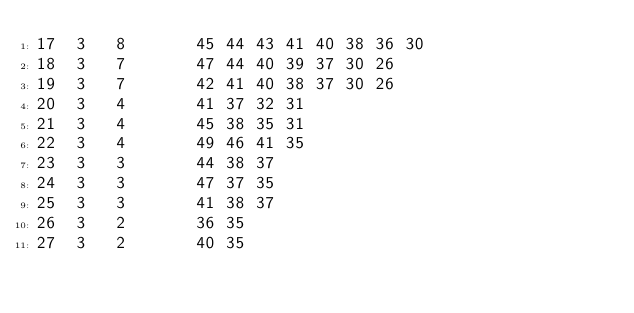<code> <loc_0><loc_0><loc_500><loc_500><_ObjectiveC_>17	3	8		45 44 43 41 40 38 36 30 
18	3	7		47 44 40 39 37 30 26 
19	3	7		42 41 40 38 37 30 26 
20	3	4		41 37 32 31 
21	3	4		45 38 35 31 
22	3	4		49 46 41 35 
23	3	3		44 38 37 
24	3	3		47 37 35 
25	3	3		41 38 37 
26	3	2		36 35 
27	3	2		40 35 </code> 